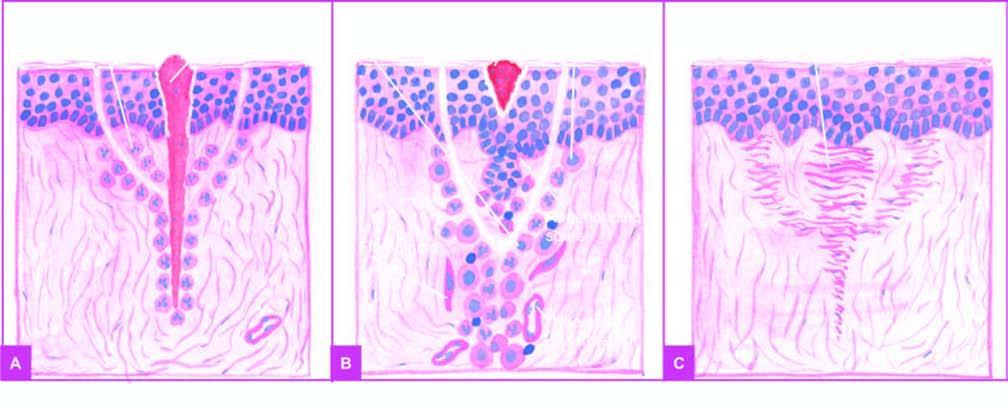does removal of suture result around 7th day result in scar tissue at the sites of incision and suture track?
Answer the question using a single word or phrase. Yes 